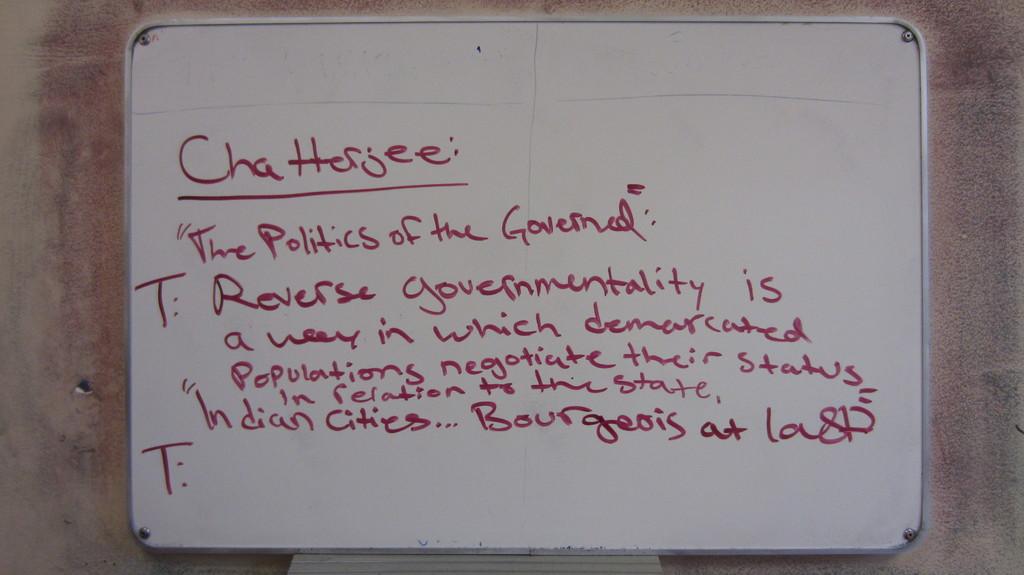What is the name of the citites?
Ensure brevity in your answer.  Bourgeois. What is the message about?
Provide a short and direct response. Politics. 